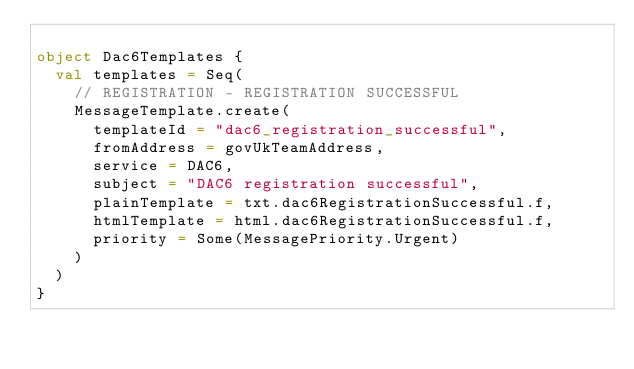<code> <loc_0><loc_0><loc_500><loc_500><_Scala_>
object Dac6Templates {
  val templates = Seq(
    // REGISTRATION - REGISTRATION SUCCESSFUL
    MessageTemplate.create(
      templateId = "dac6_registration_successful",
      fromAddress = govUkTeamAddress,
      service = DAC6,
      subject = "DAC6 registration successful",
      plainTemplate = txt.dac6RegistrationSuccessful.f,
      htmlTemplate = html.dac6RegistrationSuccessful.f,
      priority = Some(MessagePriority.Urgent)
    )
  )
}
</code> 